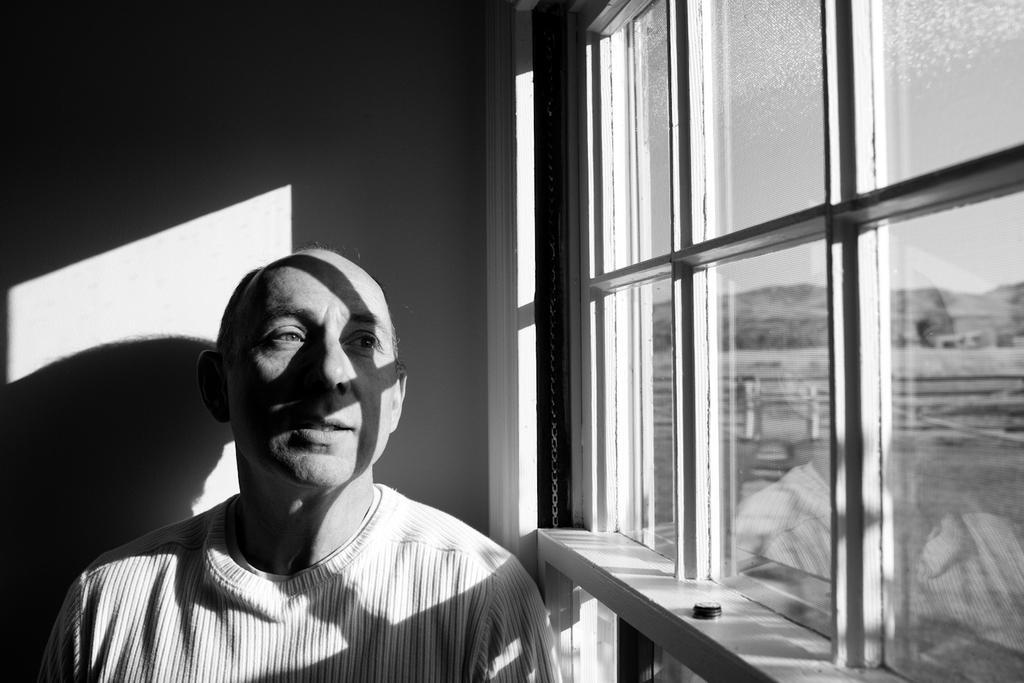Describe this image in one or two sentences. This is a black and white image. In the image we can see a man wearing clothes. Here we can see the glass window and out of the window we can see a hill and the sky. 